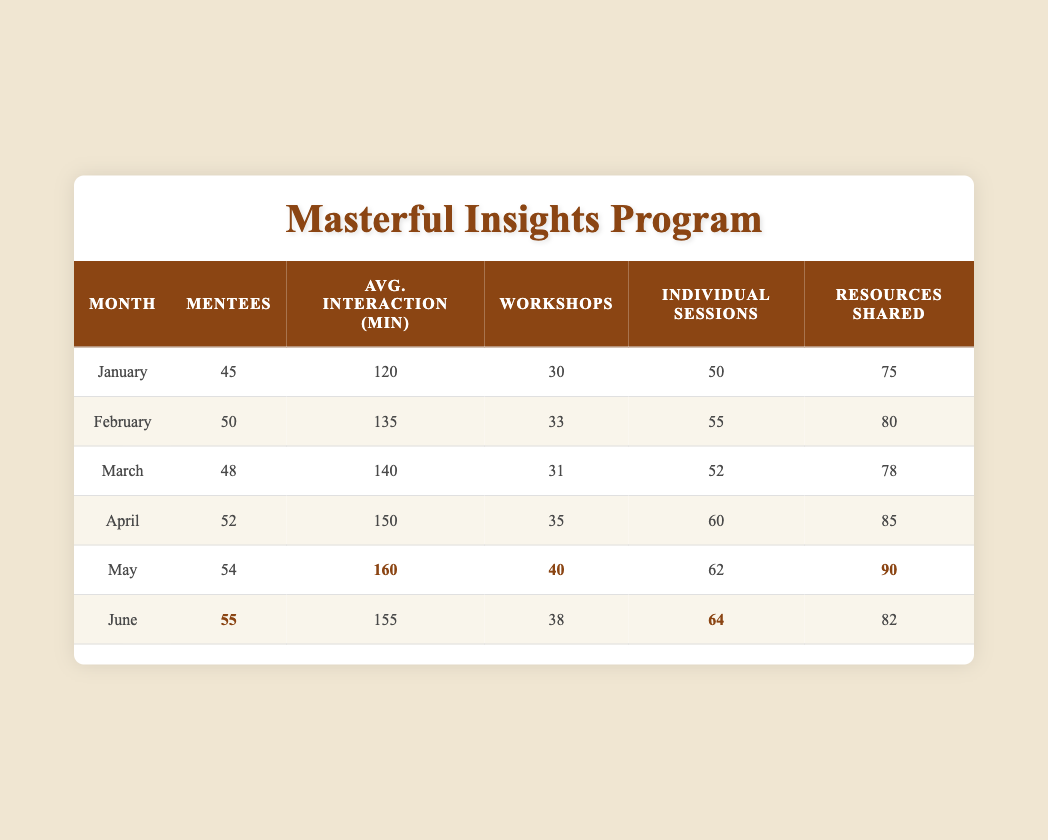What was the average interaction time in minutes for February? The table shows that the average interaction time for February is 135 minutes. Simply find the value in the corresponding row under the "Avg. Interaction (min)" column.
Answer: 135 How many workshops were attended in April? According to the table, in the month of April, 35 workshops were attended. This value is directly found in the "Workshops" column for April.
Answer: 35 What is the total number of individual sessions held from January to June? To find the total, sum the individual sessions for each month: 50 + 55 + 52 + 60 + 62 + 64 = 303. Each month's individual sessions are added together to find the total.
Answer: 303 Is the average interaction time in May greater than that in January? The average interaction time for May is 160 minutes, and for January, it is 120 minutes. Since 160 is greater than 120, the statement is true. Compare the two values from the "Avg. Interaction (min)" column.
Answer: Yes How many more resources were shared in May compared to March? In May, 90 resources were shared while in March, 78 were shared. To find the difference: 90 - 78 = 12. Subtract the value for March from that for May to determine how many more resources were shared.
Answer: 12 What was the month with the highest number of mentees? By examining the "Mentees" column, June has the highest value of 55 mentees. Check each monthly entry to identify the maximum value.
Answer: June What is the average number of workshops attended over the six months? The total workshops attended are 30 + 33 + 31 + 35 + 40 + 38 = 207. There are 6 months, so the average is 207 / 6 = 34.5. First, sum the workshops and then divide by the number of months to find the average.
Answer: 34.5 Did any month have more individual sessions than 60? Yes, in April, there were 60 individual sessions, and in May, there were 62, both of which exceed 60. Check the individual sessions for each month for comparison.
Answer: Yes Which month saw the least number of mentees? January had the least number of mentees, with a total of 45. By comparing the values in the "Mentees" column, January has the lowest figure.
Answer: January 